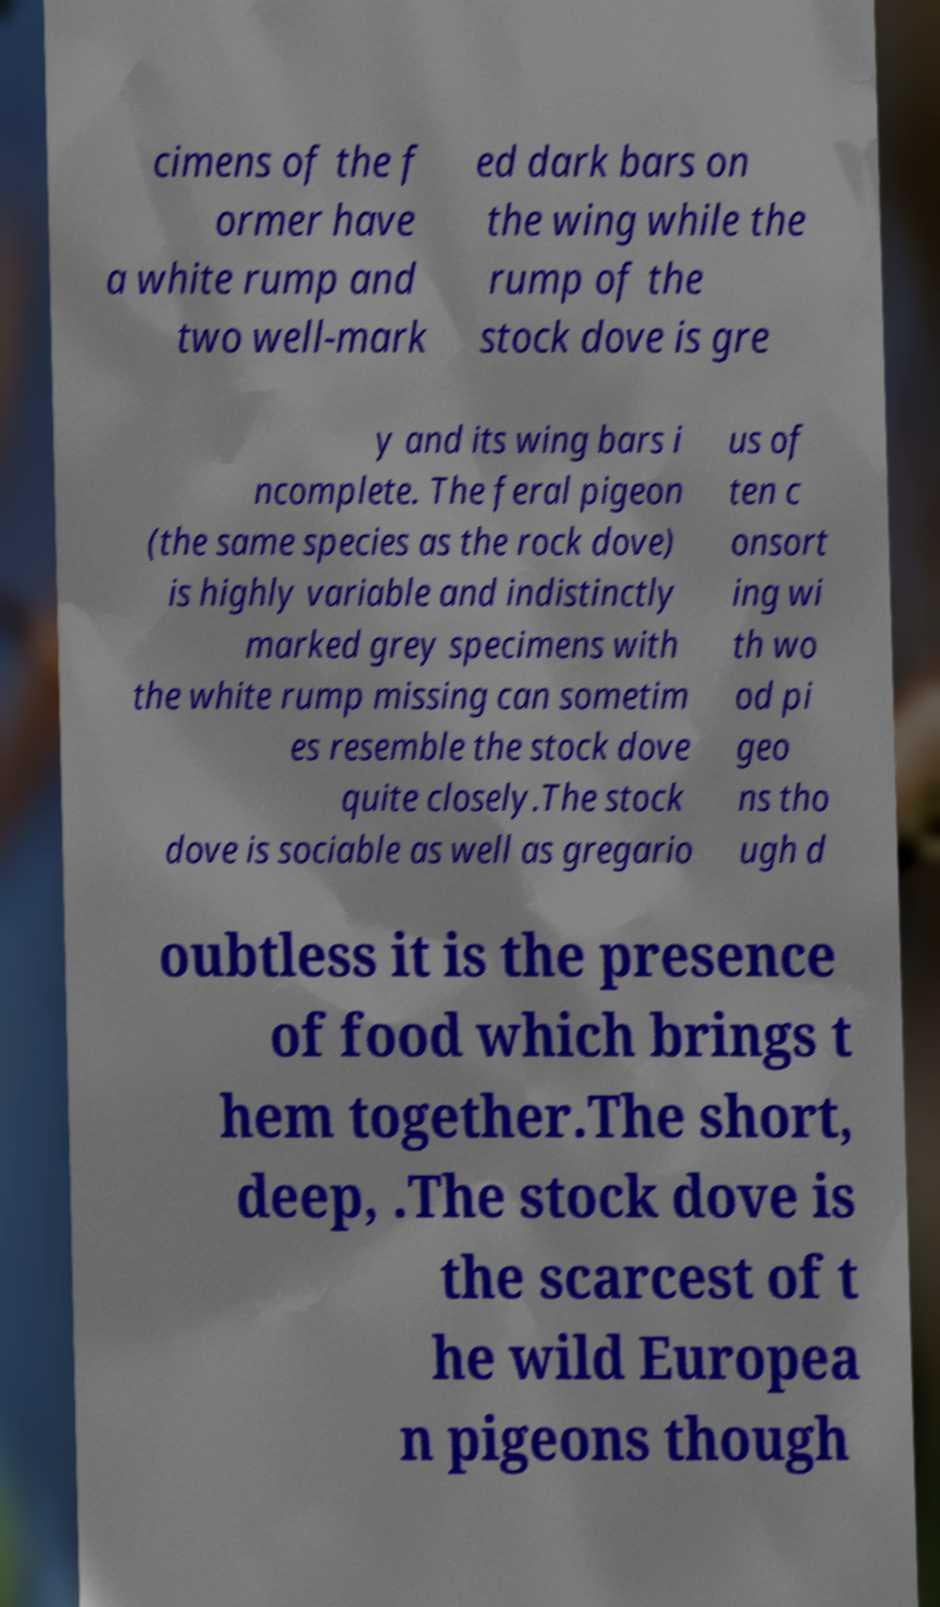Can you read and provide the text displayed in the image?This photo seems to have some interesting text. Can you extract and type it out for me? cimens of the f ormer have a white rump and two well-mark ed dark bars on the wing while the rump of the stock dove is gre y and its wing bars i ncomplete. The feral pigeon (the same species as the rock dove) is highly variable and indistinctly marked grey specimens with the white rump missing can sometim es resemble the stock dove quite closely.The stock dove is sociable as well as gregario us of ten c onsort ing wi th wo od pi geo ns tho ugh d oubtless it is the presence of food which brings t hem together.The short, deep, .The stock dove is the scarcest of t he wild Europea n pigeons though 